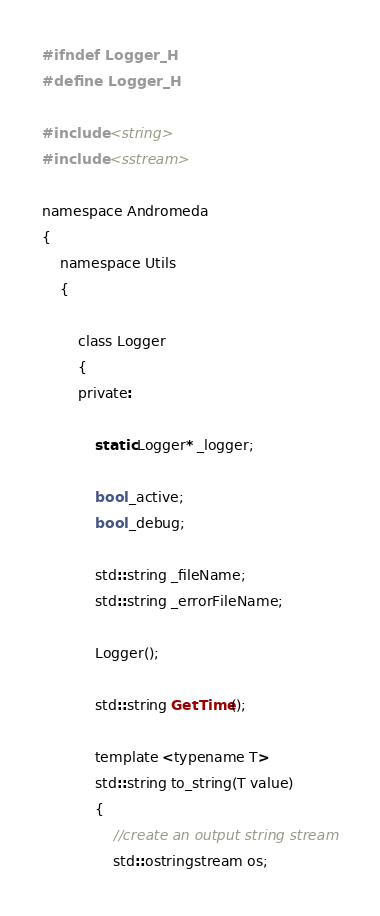Convert code to text. <code><loc_0><loc_0><loc_500><loc_500><_C_>#ifndef Logger_H
#define Logger_H

#include <string>
#include <sstream>

namespace Andromeda
{
	namespace Utils
	{

		class Logger
		{
		private:

			static Logger* _logger;
			
			bool _active;
			bool _debug;

			std::string _fileName;
			std::string _errorFileName;

			Logger();

			std::string GetTime();

			template <typename T>
			std::string to_string(T value)
			{
				//create an output string stream
				std::ostringstream os;
</code> 